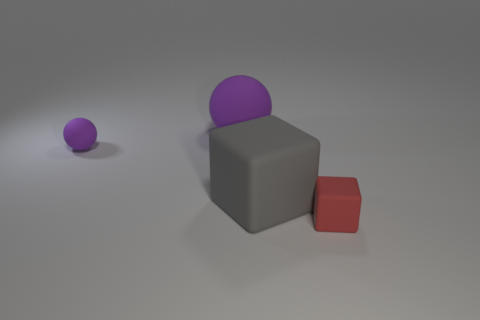Can you describe the lighting in the scene? The scene is lit from above with a soft, diffused light source casting gentle shadows beneath the objects, giving the image a calm and neutral ambience. 